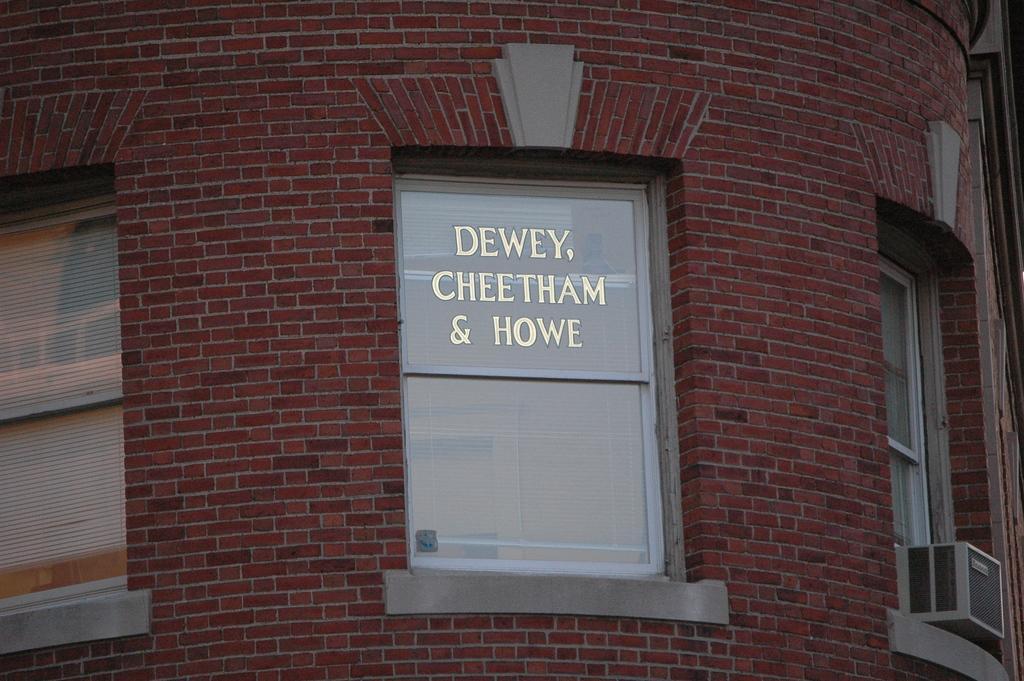Describe this image in one or two sentences. In the image we can see there are windows on the wall of the building. The wall is made up of red bricks and there is an AC outdoor unit box kept on the window. 